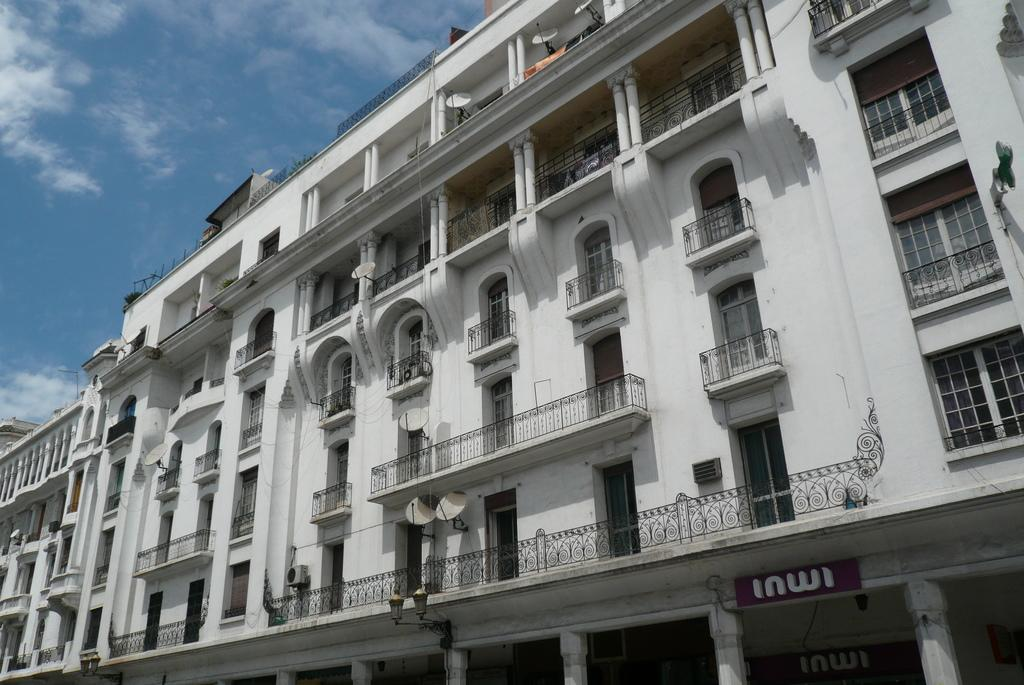What is the main structure in the image? There is a building in the image. Is there any text or writing on the building? Yes, there is text written on the building. What can be seen in the sky in the background of the image? There are clouds visible in the sky in the background of the image. What type of haircut is the building getting in the image? There is no haircut being performed on the building in the image; it is a stationary structure. What kind of stone is the building made of in the image? The facts provided do not mention the type of stone the building is made of, so we cannot determine that information from the image. 